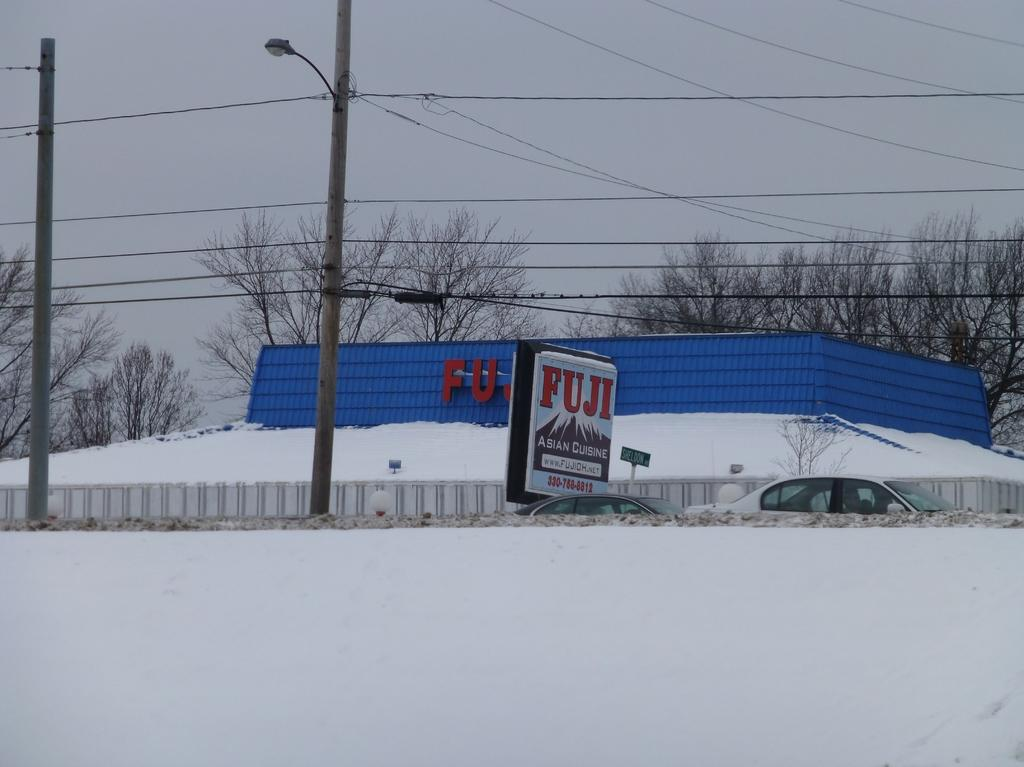<image>
Render a clear and concise summary of the photo. A restaurant named Fuji that serves Asian cuisine is covered with snow. 